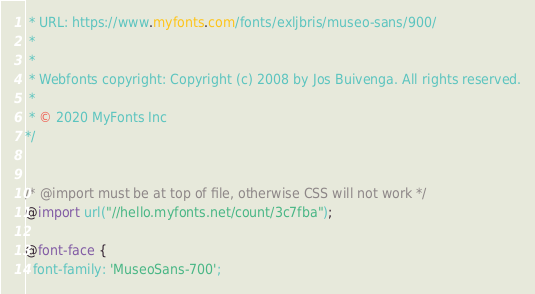<code> <loc_0><loc_0><loc_500><loc_500><_CSS_> * URL: https://www.myfonts.com/fonts/exljbris/museo-sans/900/
 * 
 * 
 * Webfonts copyright: Copyright (c) 2008 by Jos Buivenga. All rights reserved.
 * 
 * © 2020 MyFonts Inc
*/


/* @import must be at top of file, otherwise CSS will not work */
@import url("//hello.myfonts.net/count/3c7fba");
  
@font-face {
  font-family: 'MuseoSans-700';</code> 